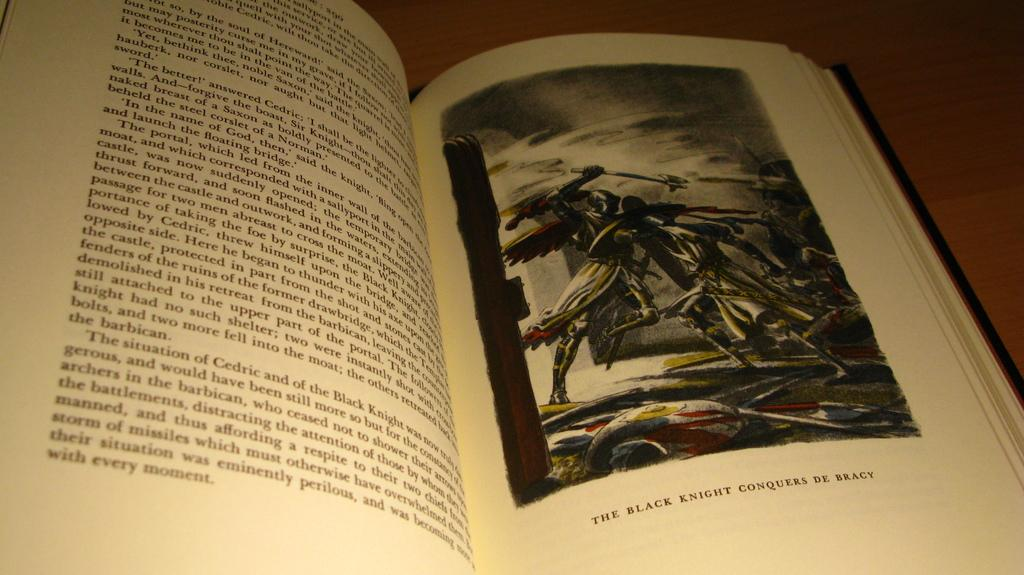<image>
Write a terse but informative summary of the picture. Two pages of a book with the right side having an image of a "black knight". 